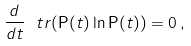<formula> <loc_0><loc_0><loc_500><loc_500>\frac { d } { d t } \ t r ( { \mathsf P } ( t ) \ln { \mathsf P } ( t ) ) = 0 \, ,</formula> 